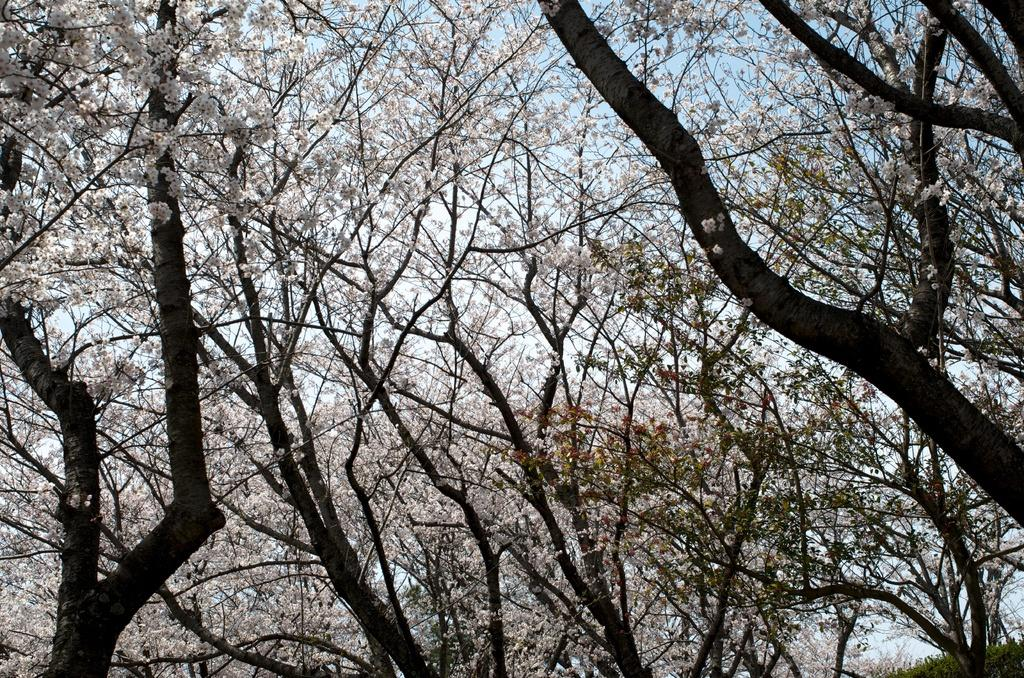What type of vegetation can be seen in the image? There are trees in the image. What part of the natural environment is visible in the image? The sky is visible in the background of the image. What type of food is hanging from the trees in the image? There is no food hanging from the trees in the image; only trees and the sky are visible. How many beds can be seen in the image? There are no beds present in the image. 